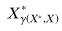<formula> <loc_0><loc_0><loc_500><loc_500>X _ { \gamma ( X ^ { * } , X ) } ^ { * }</formula> 